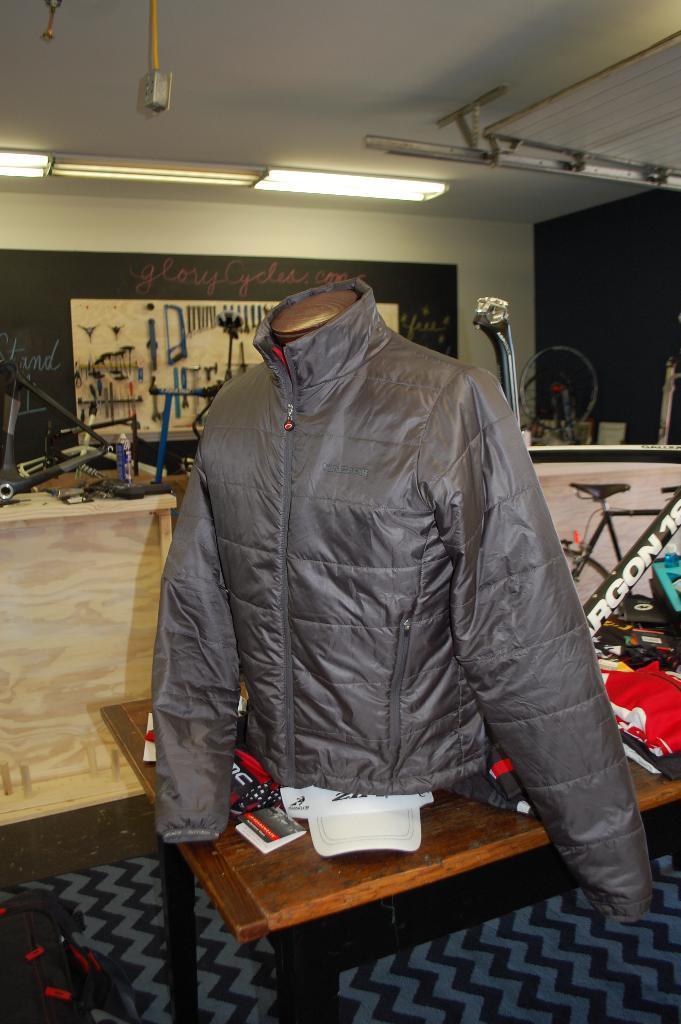In one or two sentences, can you explain what this image depicts? There is a coat on a table. In the background we can see bicycle,table,spare parts of a bicycle,wall,lights. 